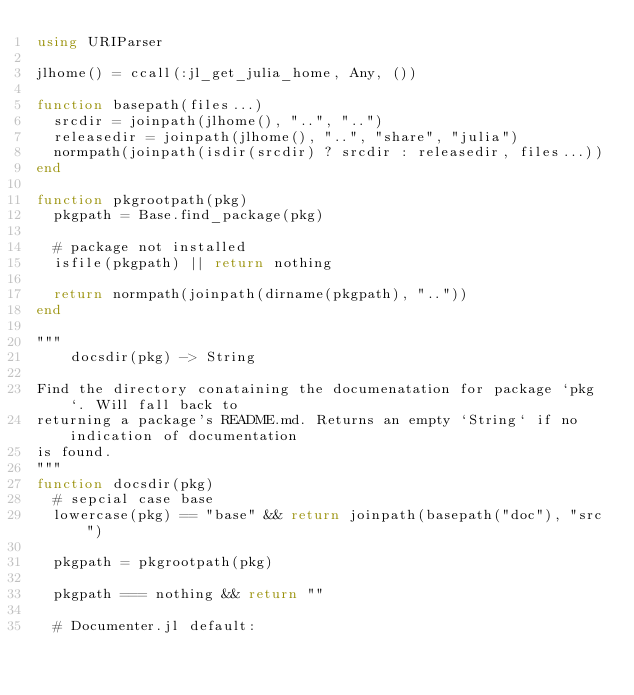<code> <loc_0><loc_0><loc_500><loc_500><_Julia_>using URIParser

jlhome() = ccall(:jl_get_julia_home, Any, ())

function basepath(files...)
  srcdir = joinpath(jlhome(), "..", "..")
  releasedir = joinpath(jlhome(), "..", "share", "julia")
  normpath(joinpath(isdir(srcdir) ? srcdir : releasedir, files...))
end

function pkgrootpath(pkg)
  pkgpath = Base.find_package(pkg)

  # package not installed
  isfile(pkgpath) || return nothing

  return normpath(joinpath(dirname(pkgpath), ".."))
end

"""
    docsdir(pkg) -> String

Find the directory conataining the documenatation for package `pkg`. Will fall back to
returning a package's README.md. Returns an empty `String` if no indication of documentation
is found.
"""
function docsdir(pkg)
  # sepcial case base
  lowercase(pkg) == "base" && return joinpath(basepath("doc"), "src")

  pkgpath = pkgrootpath(pkg)

  pkgpath === nothing && return ""

  # Documenter.jl default:</code> 